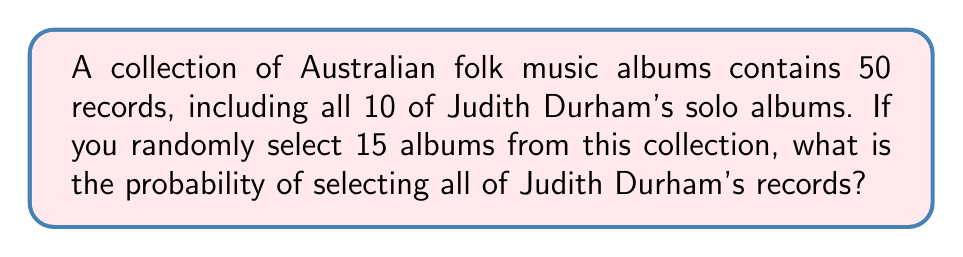Provide a solution to this math problem. Let's approach this step-by-step:

1) We need to use the hypergeometric distribution, as we are selecting without replacement from a finite population.

2) We want the probability of selecting all 10 of Judith Durham's albums out of the 15 albums we're selecting.

3) The remaining 5 albums must come from the other 40 albums in the collection.

4) We can calculate this using the following formula:

   $$P(\text{all Judith Durham albums}) = \frac{\binom{10}{10} \cdot \binom{40}{5}}{\binom{50}{15}}$$

5) Let's calculate each part:
   
   $\binom{10}{10} = 1$ (there's only one way to choose all 10 albums)
   
   $\binom{40}{5} = 658,008$ (ways to choose 5 from the remaining 40)
   
   $\binom{50}{15} = 2,250,829,575$ (total ways to choose 15 from 50)

6) Putting it all together:

   $$P = \frac{1 \cdot 658,008}{2,250,829,575} = \frac{658,008}{2,250,829,575} \approx 0.0002923$$

7) Converting to a percentage:

   $0.0002923 \cdot 100\% \approx 0.02923\%$
Answer: $\frac{658,008}{2,250,829,575} \approx 0.02923\%$ 